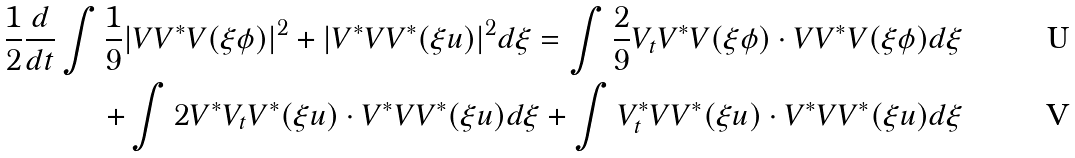Convert formula to latex. <formula><loc_0><loc_0><loc_500><loc_500>\frac { 1 } { 2 } \frac { d } { d t } \int \frac { 1 } { 9 } | V V ^ { \ast } V ( \xi \phi ) | ^ { 2 } + | V ^ { \ast } V V ^ { \ast } ( \xi u ) | ^ { 2 } d \xi = \int \frac { 2 } { 9 } V _ { t } V ^ { \ast } V ( \xi \phi ) \cdot V V ^ { \ast } V ( \xi \phi ) d \xi \\ + \int 2 V ^ { \ast } V _ { t } V ^ { \ast } ( \xi u ) \cdot V ^ { \ast } V V ^ { \ast } ( \xi u ) d \xi + \int V _ { t } ^ { \ast } V V ^ { \ast } ( \xi u ) \cdot V ^ { \ast } V V ^ { \ast } ( \xi u ) d \xi</formula> 